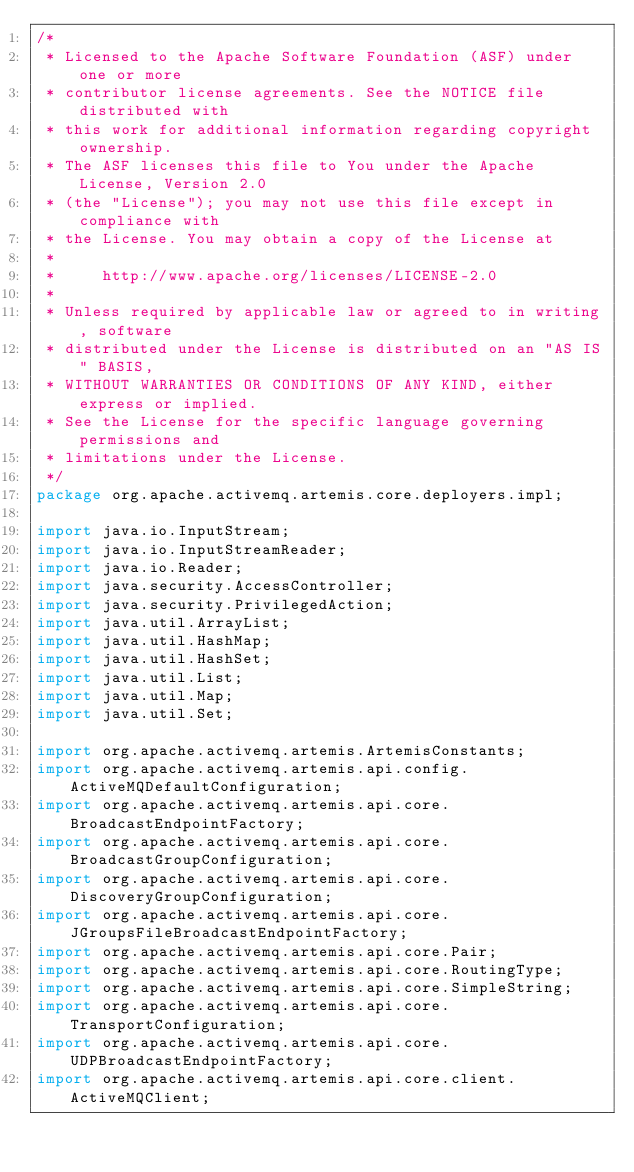<code> <loc_0><loc_0><loc_500><loc_500><_Java_>/*
 * Licensed to the Apache Software Foundation (ASF) under one or more
 * contributor license agreements. See the NOTICE file distributed with
 * this work for additional information regarding copyright ownership.
 * The ASF licenses this file to You under the Apache License, Version 2.0
 * (the "License"); you may not use this file except in compliance with
 * the License. You may obtain a copy of the License at
 *
 *     http://www.apache.org/licenses/LICENSE-2.0
 *
 * Unless required by applicable law or agreed to in writing, software
 * distributed under the License is distributed on an "AS IS" BASIS,
 * WITHOUT WARRANTIES OR CONDITIONS OF ANY KIND, either express or implied.
 * See the License for the specific language governing permissions and
 * limitations under the License.
 */
package org.apache.activemq.artemis.core.deployers.impl;

import java.io.InputStream;
import java.io.InputStreamReader;
import java.io.Reader;
import java.security.AccessController;
import java.security.PrivilegedAction;
import java.util.ArrayList;
import java.util.HashMap;
import java.util.HashSet;
import java.util.List;
import java.util.Map;
import java.util.Set;

import org.apache.activemq.artemis.ArtemisConstants;
import org.apache.activemq.artemis.api.config.ActiveMQDefaultConfiguration;
import org.apache.activemq.artemis.api.core.BroadcastEndpointFactory;
import org.apache.activemq.artemis.api.core.BroadcastGroupConfiguration;
import org.apache.activemq.artemis.api.core.DiscoveryGroupConfiguration;
import org.apache.activemq.artemis.api.core.JGroupsFileBroadcastEndpointFactory;
import org.apache.activemq.artemis.api.core.Pair;
import org.apache.activemq.artemis.api.core.RoutingType;
import org.apache.activemq.artemis.api.core.SimpleString;
import org.apache.activemq.artemis.api.core.TransportConfiguration;
import org.apache.activemq.artemis.api.core.UDPBroadcastEndpointFactory;
import org.apache.activemq.artemis.api.core.client.ActiveMQClient;</code> 